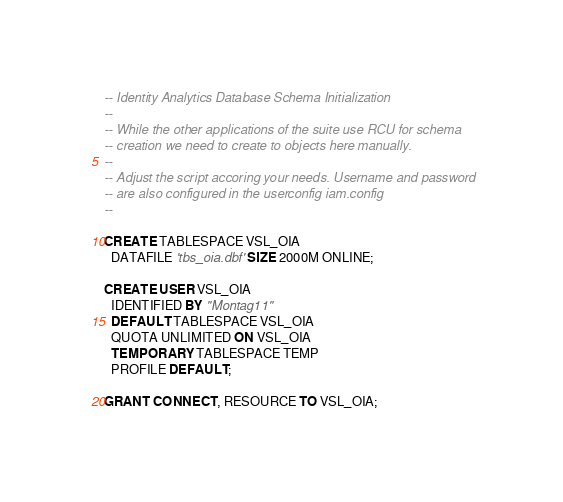<code> <loc_0><loc_0><loc_500><loc_500><_SQL_>-- Identity Analytics Database Schema Initialization
-- 
-- While the other applications of the suite use RCU for schema 
-- creation we need to create to objects here manually.
--
-- Adjust the script accoring your needs. Username and password
-- are also configured in the userconfig iam.config
--

CREATE TABLESPACE VSL_OIA
  DATAFILE 'tbs_oia.dbf' SIZE 2000M ONLINE;

CREATE USER VSL_OIA 
  IDENTIFIED BY "Montag11"
  DEFAULT TABLESPACE VSL_OIA
  QUOTA UNLIMITED ON VSL_OIA
  TEMPORARY TABLESPACE TEMP
  PROFILE DEFAULT;

GRANT CONNECT, RESOURCE TO VSL_OIA;

</code> 